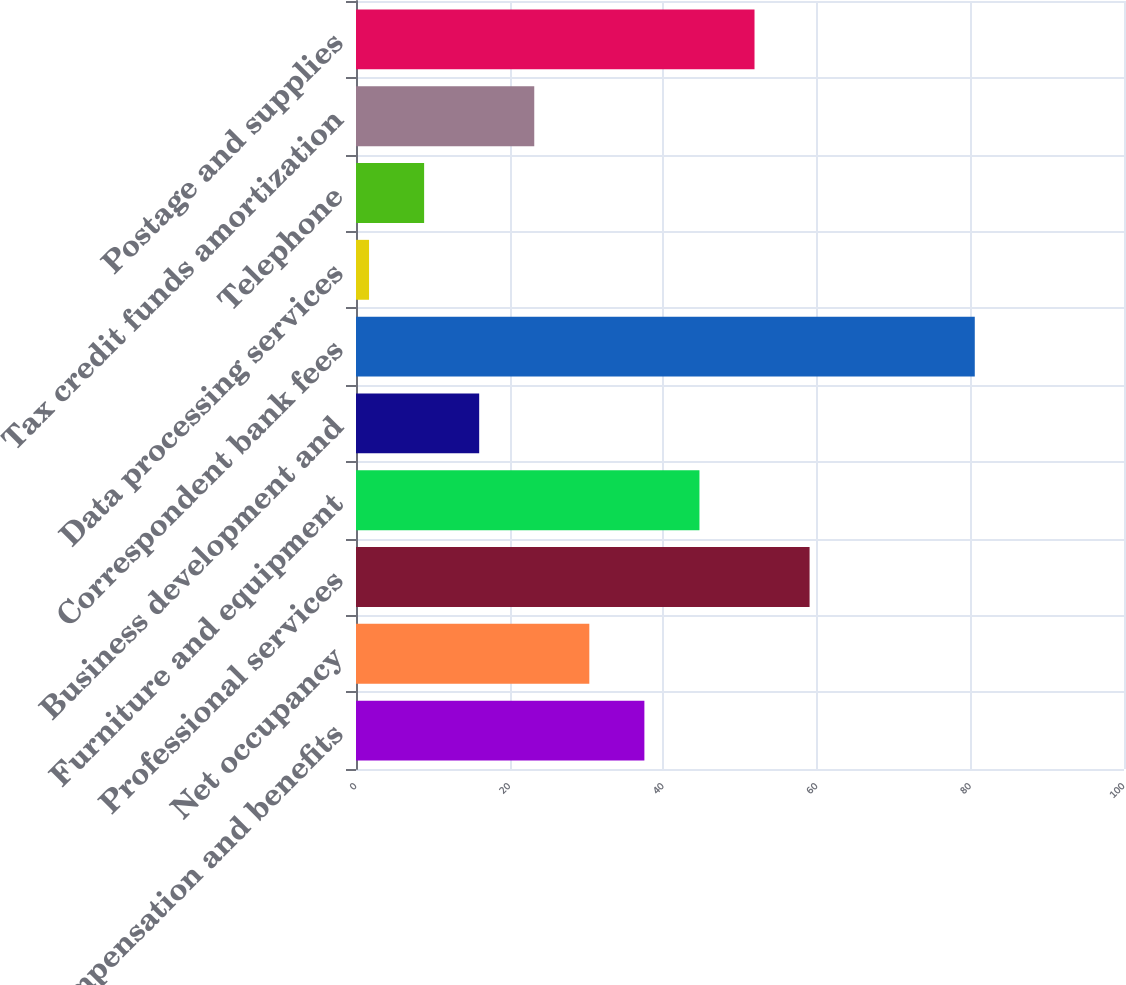<chart> <loc_0><loc_0><loc_500><loc_500><bar_chart><fcel>Compensation and benefits<fcel>Net occupancy<fcel>Professional services<fcel>Furniture and equipment<fcel>Business development and<fcel>Correspondent bank fees<fcel>Data processing services<fcel>Telephone<fcel>Tax credit funds amortization<fcel>Postage and supplies<nl><fcel>37.55<fcel>30.38<fcel>59.06<fcel>44.72<fcel>16.04<fcel>80.57<fcel>1.7<fcel>8.87<fcel>23.21<fcel>51.89<nl></chart> 